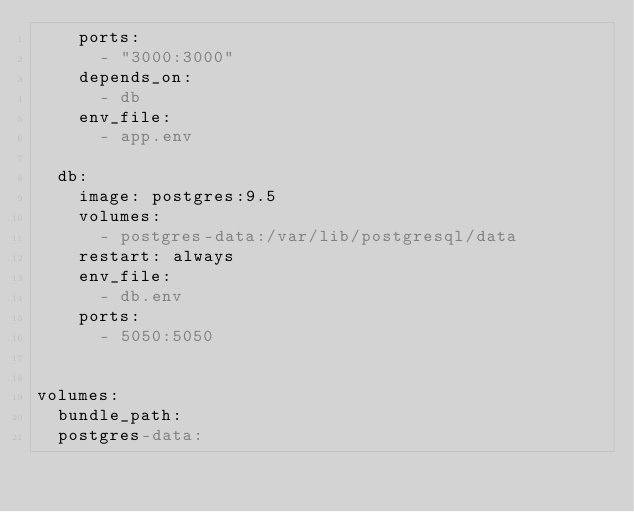<code> <loc_0><loc_0><loc_500><loc_500><_YAML_>    ports:
      - "3000:3000"
    depends_on:
      - db
    env_file:
      - app.env

  db:
    image: postgres:9.5
    volumes:
      - postgres-data:/var/lib/postgresql/data
    restart: always
    env_file:
      - db.env
    ports:
      - 5050:5050
      
    
volumes:
  bundle_path:
  postgres-data:
</code> 